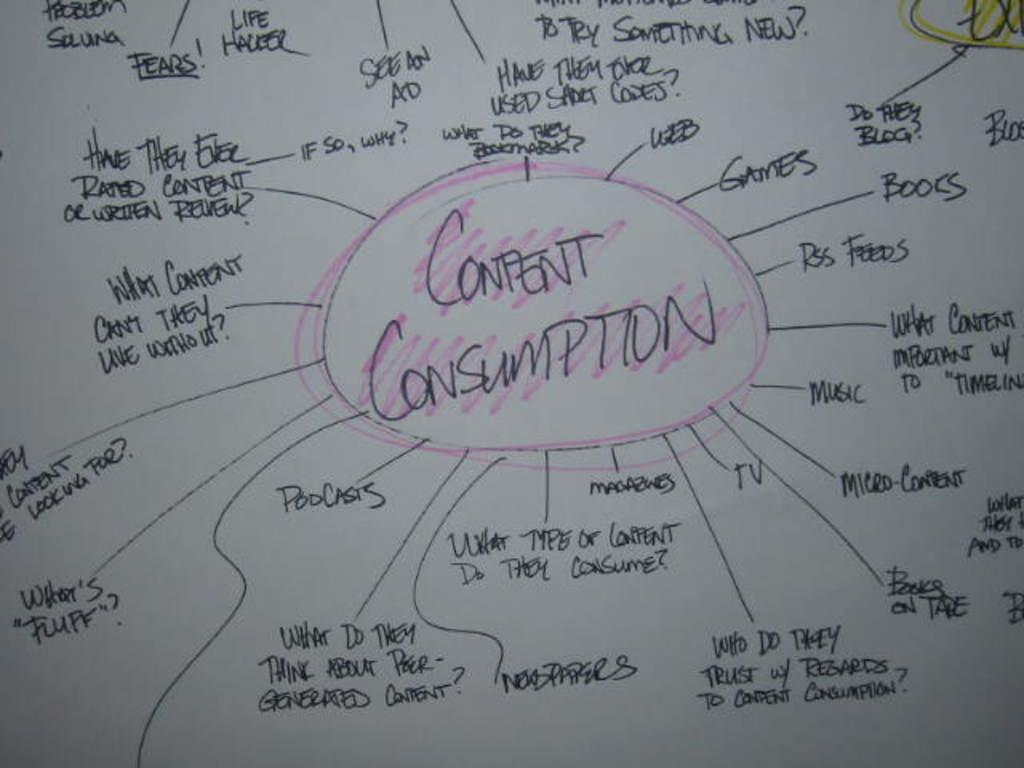<image>
Render a clear and concise summary of the photo. Graph or chart that has the words "Content Consumption" in the middle and colored in pink. 